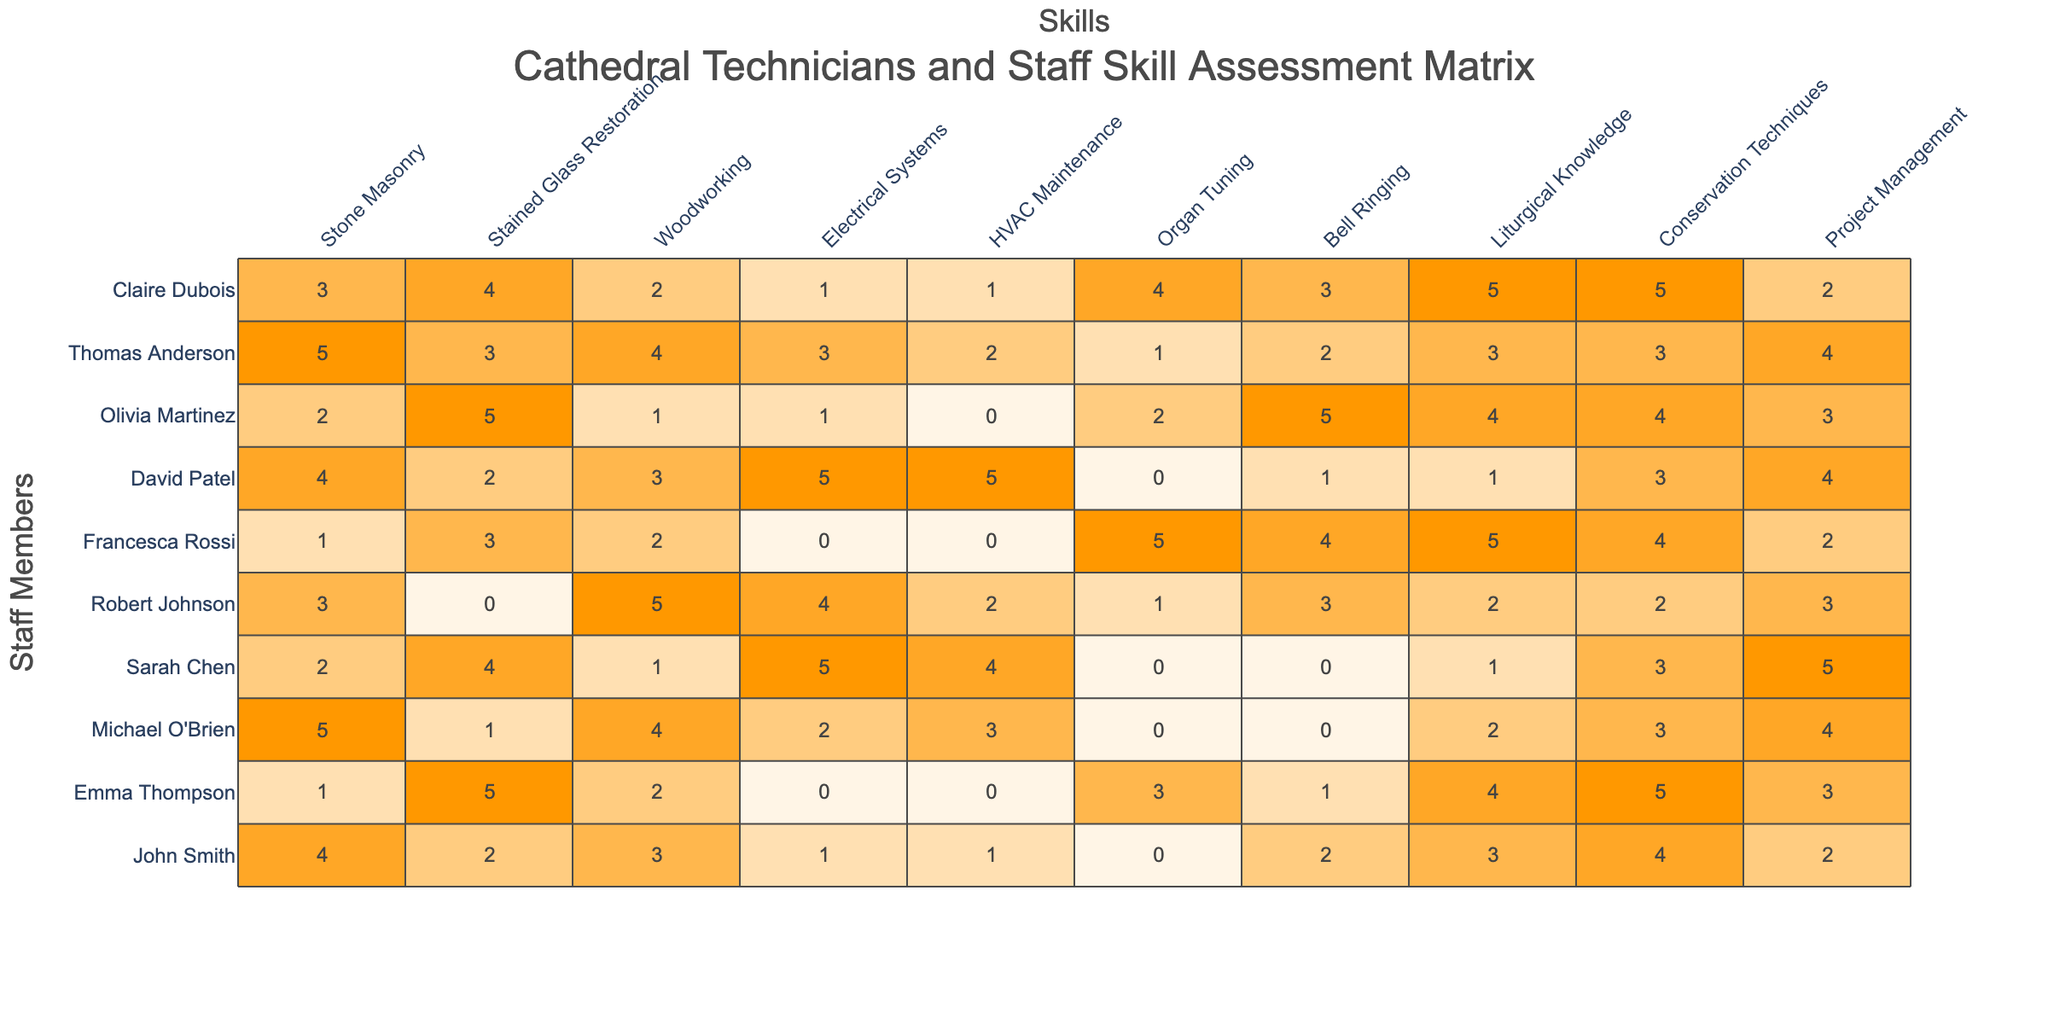What is the highest skill level in Stone Masonry? Looking at the Stone Masonry row, Michael O'Brien has the highest level of 5.
Answer: 5 Which technician has the lowest skill level in Liturgical Knowledge? In the Liturgical Knowledge column, both Michael O'Brien and Sarah Chen have a skill level of 0, making it the lowest.
Answer: 0 What is the average skill level in Woodworking across all technicians? The skill levels for Woodworking are 3, 2, 4, 1, 5, 2, 3, 1, 4, 2. Summing them gives 3 + 2 + 4 + 1 + 5 + 2 + 3 + 1 + 4 + 2 = 27. Dividing by the number of technicians (10), the average is 27/10 = 2.7.
Answer: 2.7 Which technician has the best overall skill score? Summing the skills for each technician, Michael O'Brien has a total score of 21, which is higher than any other technician's total.
Answer: Michael O'Brien Is there anyone who has a skill level of 0 in Electrical Systems? Yes, both Emma Thompson and Francesca Rossi have a skill level of 0 in Electrical Systems.
Answer: Yes What is the range of skill levels for HVAC Maintenance? The highest skill level is 5 (David Patel) and the lowest is 0 (Emma Thompson and Francesca Rossi). The range is calculated as highest - lowest = 5 - 0 = 5.
Answer: 5 How many technicians have a skill level of 5 in Stained Glass Restoration? Looking at the Stained Glass Restoration column, only Emma Thompson and Olivia Martinez have a skill level of 5, which totals 2 technicians.
Answer: 2 Which technician scored the highest in Conservation Techniques, and what is their score? Sarah Chen and Emma Thompson both scored 5 in Conservation Techniques, making them the highest scorers in that category.
Answer: Sarah Chen and Emma Thompson, score 5 What is the most common skill level for Bell Ringing among all technicians? By examining the Bell Ringing column, the skill levels are 2, 3, 0, 0, 1, 5, 1, 5, 2, and 3. The most frequent score is 0, appearing twice.
Answer: 0 Which technician has the best score in both Project Management and Stone Masonry combined? The best scores in Project Management are 4 (John Smith, Michael O'Brien) and in Stone Masonry is 5 (Michael O'Brien). Combining these values gives 5 + 4 = 9 for Michael O'Brien. No other technician can achieve a higher combined score.
Answer: 9 